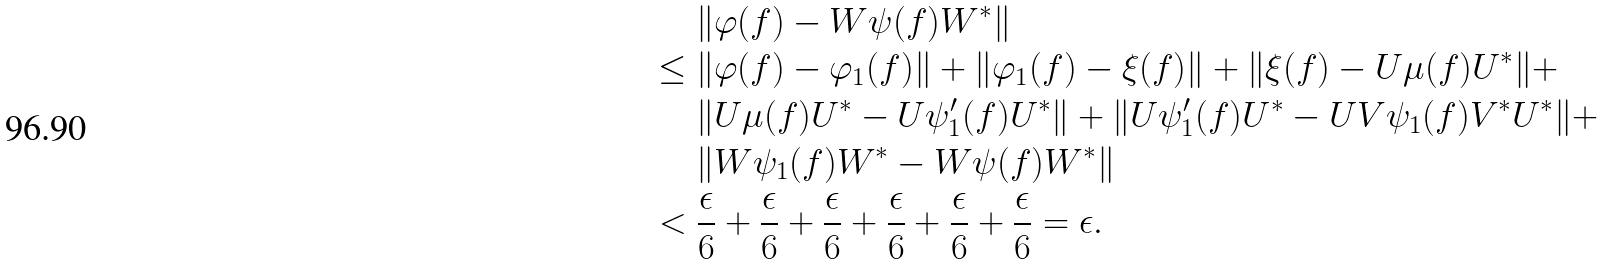<formula> <loc_0><loc_0><loc_500><loc_500>& \| \varphi ( f ) - W \psi ( f ) W ^ { * } \| \\ \leq \ & \| \varphi ( f ) - \varphi _ { 1 } ( f ) \| + \| \varphi _ { 1 } ( f ) - \xi ( f ) \| + \| \xi ( f ) - U \mu ( f ) U ^ { * } \| + \\ & \| U \mu ( f ) U ^ { * } - U \psi _ { 1 } ^ { \prime } ( f ) U ^ { * } \| + \| U \psi _ { 1 } ^ { \prime } ( f ) U ^ { * } - U V \psi _ { 1 } ( f ) V ^ { * } U ^ { * } \| + \\ & \| W \psi _ { 1 } ( f ) W ^ { * } - W \psi ( f ) W ^ { * } \| \\ < \ & \frac { \epsilon } 6 + \frac { \epsilon } 6 + \frac { \epsilon } 6 + \frac { \epsilon } 6 + \frac { \epsilon } 6 + \frac { \epsilon } 6 = \epsilon .</formula> 